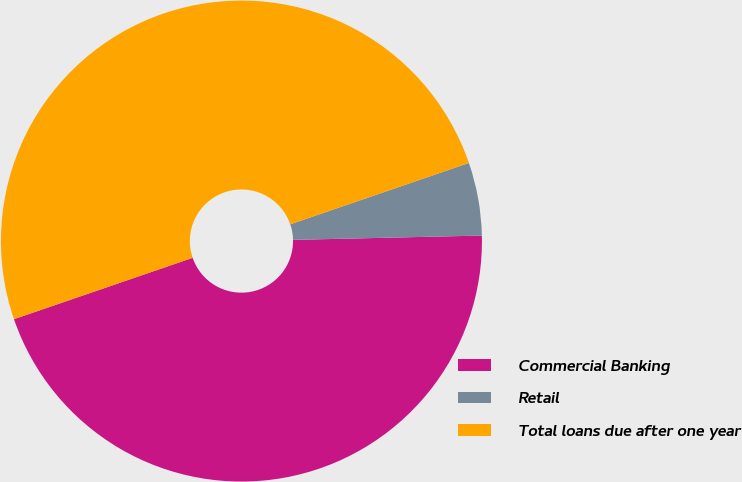Convert chart to OTSL. <chart><loc_0><loc_0><loc_500><loc_500><pie_chart><fcel>Commercial Banking<fcel>Retail<fcel>Total loans due after one year<nl><fcel>45.1%<fcel>4.9%<fcel>50.0%<nl></chart> 